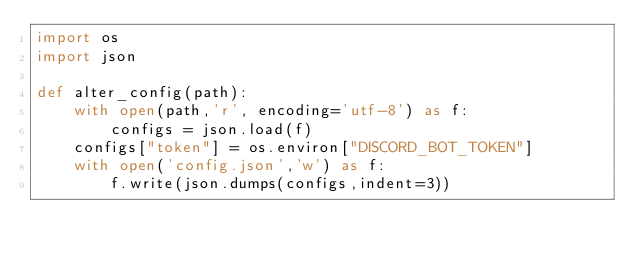Convert code to text. <code><loc_0><loc_0><loc_500><loc_500><_Python_>import os
import json

def alter_config(path):
    with open(path,'r', encoding='utf-8') as f:
        configs = json.load(f)
    configs["token"] = os.environ["DISCORD_BOT_TOKEN"]
    with open('config.json','w') as f:
        f.write(json.dumps(configs,indent=3))
</code> 